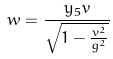<formula> <loc_0><loc_0><loc_500><loc_500>w = \frac { y _ { 5 } v } { \sqrt { 1 - \frac { v ^ { 2 } } { g ^ { 2 } } } }</formula> 